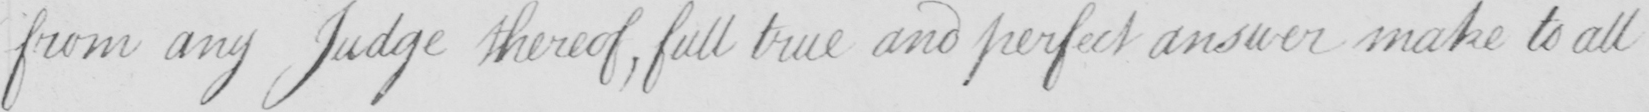Please transcribe the handwritten text in this image. from any Judge thereof  , full true and perfect answer make to all 